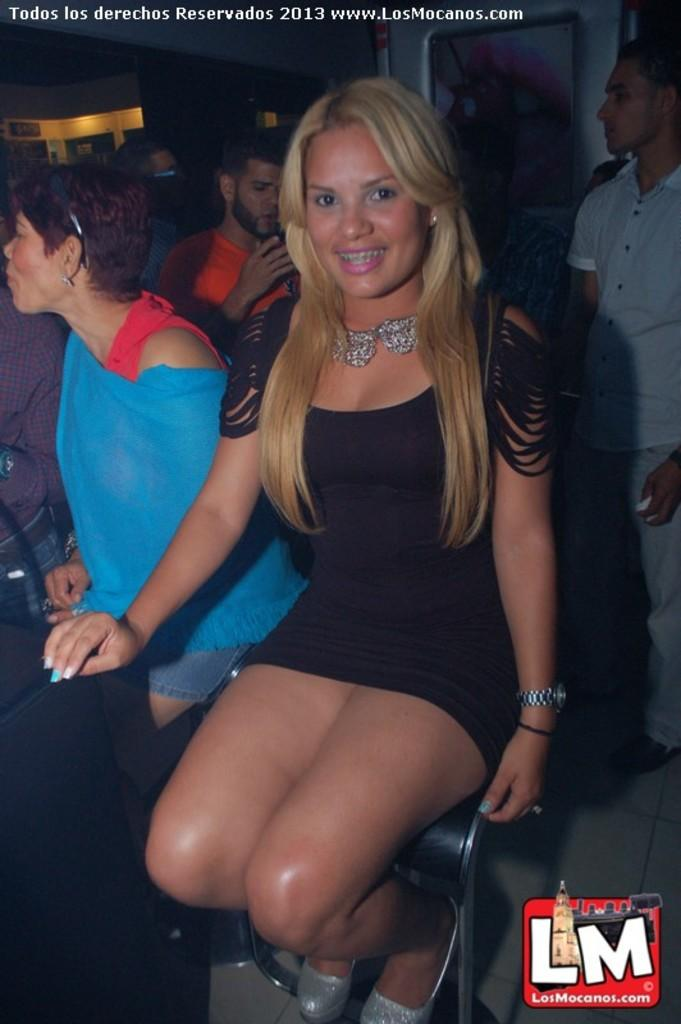How many people are present in the image? There are many people in the image. What are some of the people doing in the image? Some people are sitting on chairs. Where can the watermark be found in the image? The watermark is in the right bottom corner of the image. What is written at the top of the image? There is text at the top of the image. What can be seen in the background of the image? There is a wall with a photo in the background. Can you tell me the reason why the sheet is floating on the lake in the image? There is no sheet or lake present in the image, so it is not possible to determine the reason for a sheet floating on a lake. 